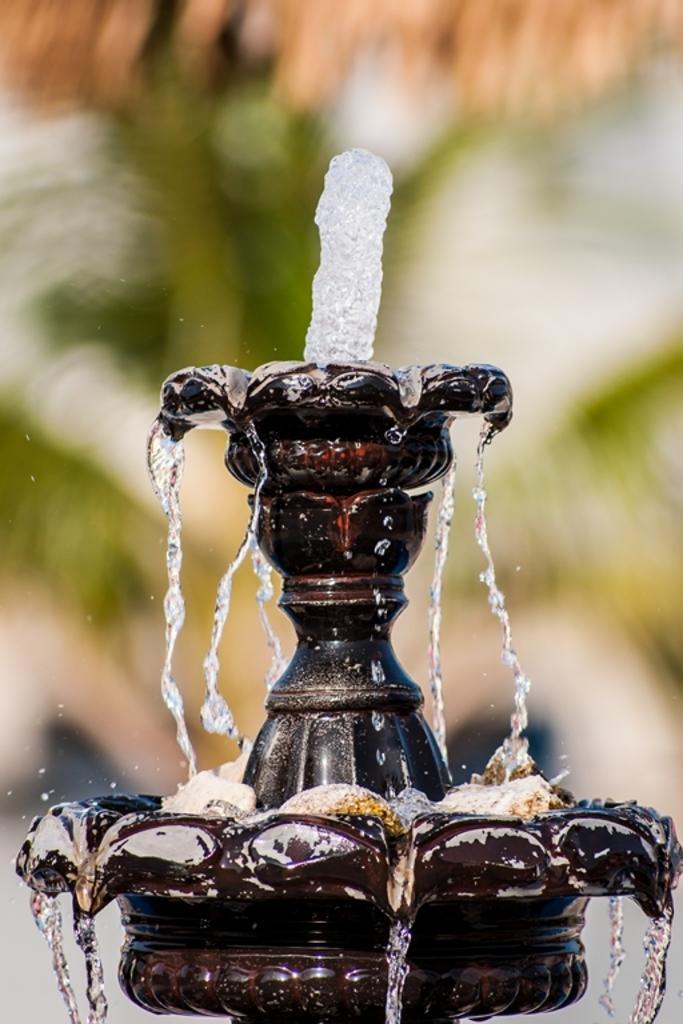How would you summarize this image in a sentence or two? In this picture we can see a fountain and in the background we can see it is blurry. 